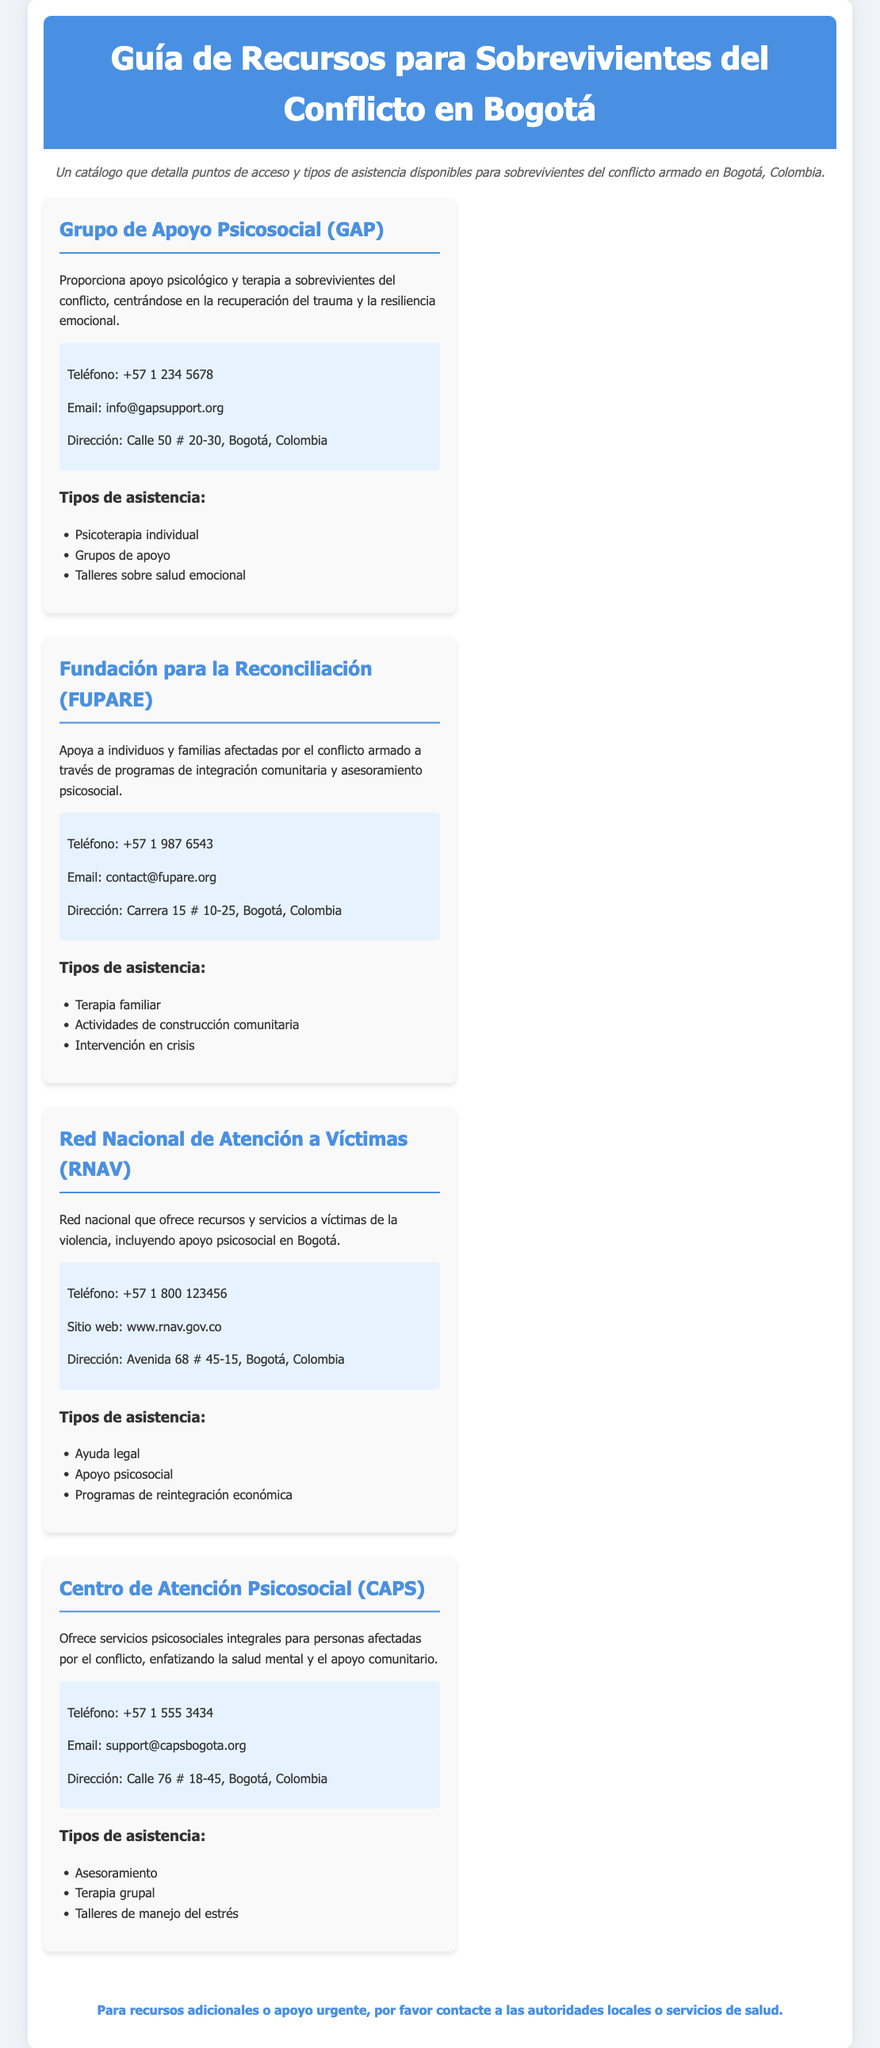¿Qué tipo de asistencia ofrece el Grupo de Apoyo Psicosocial? La asistencia del Grupo de Apoyo Psicosocial incluye psicoterapia individual, grupos de apoyo y talleres sobre salud emocional.
Answer: Psicoterapia individual, grupos de apoyo, talleres sobre salud emocional ¿Cuál es el teléfono de la Fundación para la Reconciliación? El teléfono de la Fundación para la Reconciliación se encuentra en la información de contacto proporcionada.
Answer: +57 1 987 6543 ¿Dónde se ubica el Centro de Atención Psicosocial? La ubicación del Centro de Atención Psicosocial está especificada en su información de contacto.
Answer: Calle 76 # 18-45, Bogotá, Colombia ¿Qué servicio ofrece la Red Nacional de Atención a Víctimas? La Red Nacional de Atención a Víctimas ofrece recursos y servicios a víctimas de la violencia, incluyendo apoyo psicosocial.
Answer: Apoyo psicosocial ¿Cuáles son las actividades de la Fundación para la Reconciliación? Las actividades incluyen terapia familiar, actividades de construcción comunitaria y intervención en crisis.
Answer: Terapia familiar, actividades de construcción comunitaria, intervención en crisis ¿A cuántos tipos de asistencia se puede acceder en el CAPS? La cantidad de tipos de asistencia en el CAPS permite hacer un recuento de los servicios ofrecidos.
Answer: Tres tipos ¿Qué tipo de terapia se ofrece en el Grupo de Apoyo Psicosocial? En el documento se especifica el enfoque de la terapia que se brinda.
Answer: Terapia ¿Cuál es el objetivo del apoyo psicosocial de la RNAV? Se busca entender el enfoque de la RNAV en el contexto de apoyo a las víctimas de la violencia.
Answer: Apoyo psicosocial ¿Quiénes pueden beneficiarse de los programas de la Fundación para la Reconciliación? La Fundación está orientada a las personas y familias afectadas por el conflicto armado.
Answer: Individuos y familias afectadas 